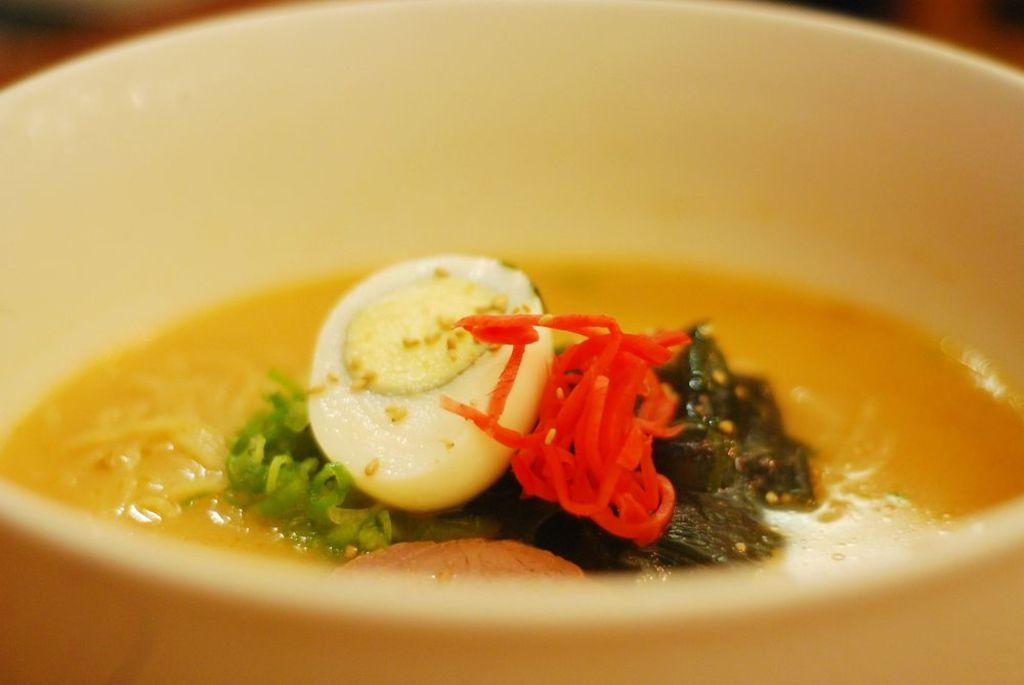What is in the bowl that is visible in the image? There is a bowl containing soup in the image. What type of ingredients can be found in the soup? The soup has noodles, mint, tomato, pieces (possibly of meat or vegetables), and a boiled egg in it. Where is the bowl located in the image? The bowl is placed on a table. What type of fruit can be seen hanging from the rail in the image? There is no rail or fruit present in the image. What prose is being recited by the person in the image? There is no person or prose recitation present in the image. 